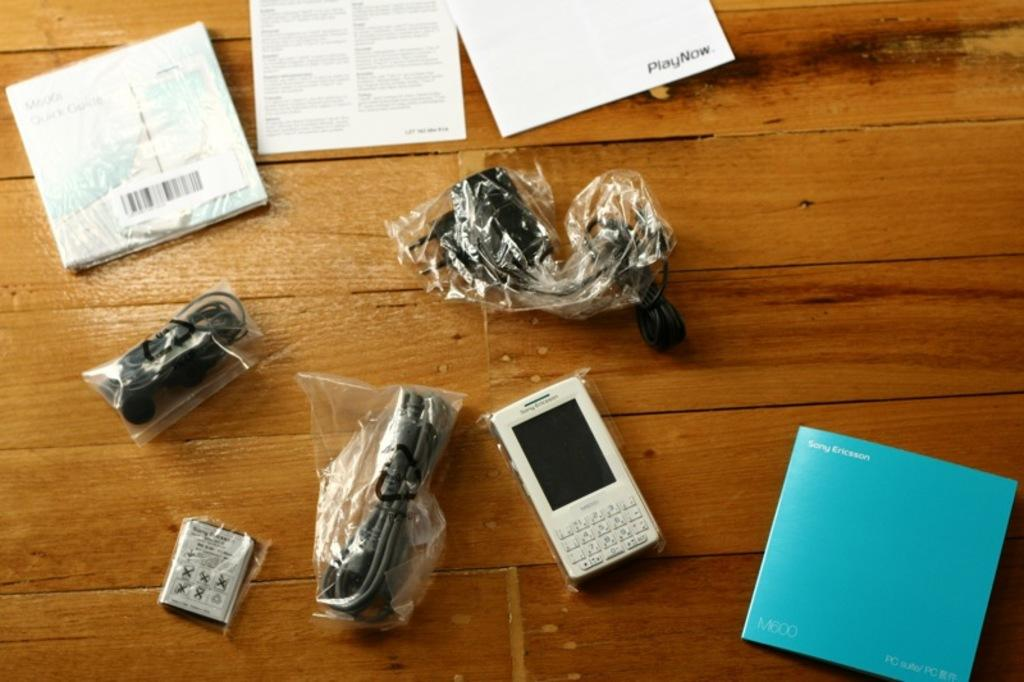<image>
Provide a brief description of the given image. A Sony Ericsson phone and all the stuff that came with it are sprawled out on a wooden table. 